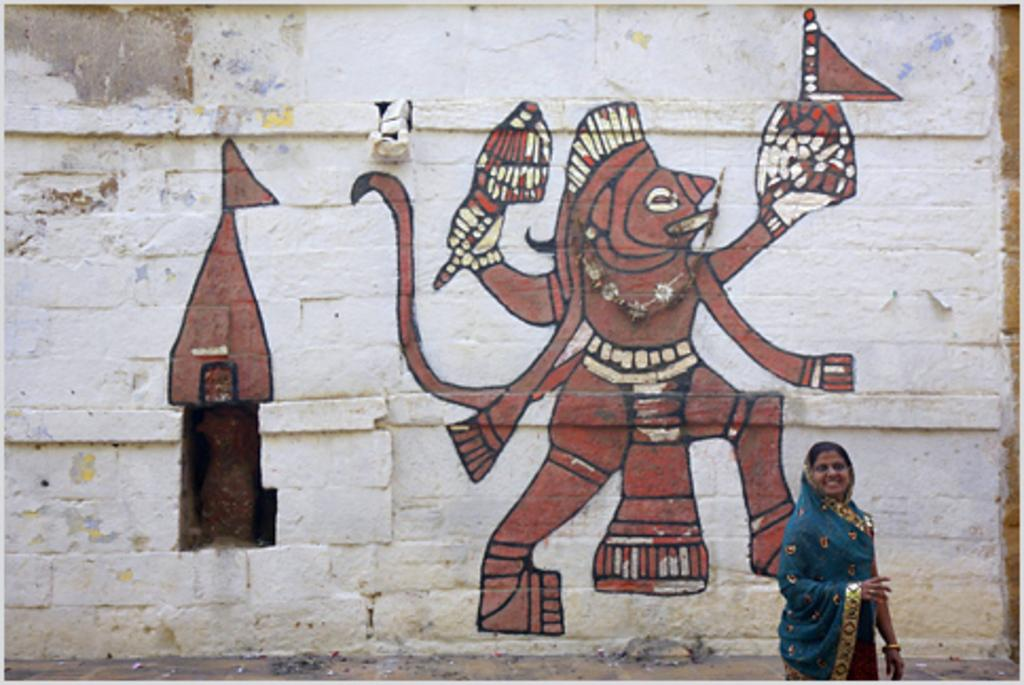What is depicted on the wall in the image? There is a painting on the wall in the image. Can you describe the woman in the image? There is a woman wearing a sari in the bottom right corner of the image. How many ducks are visible in the image? There are no ducks present in the image. What is the tendency of the trains in the image? There are no trains present in the image. 